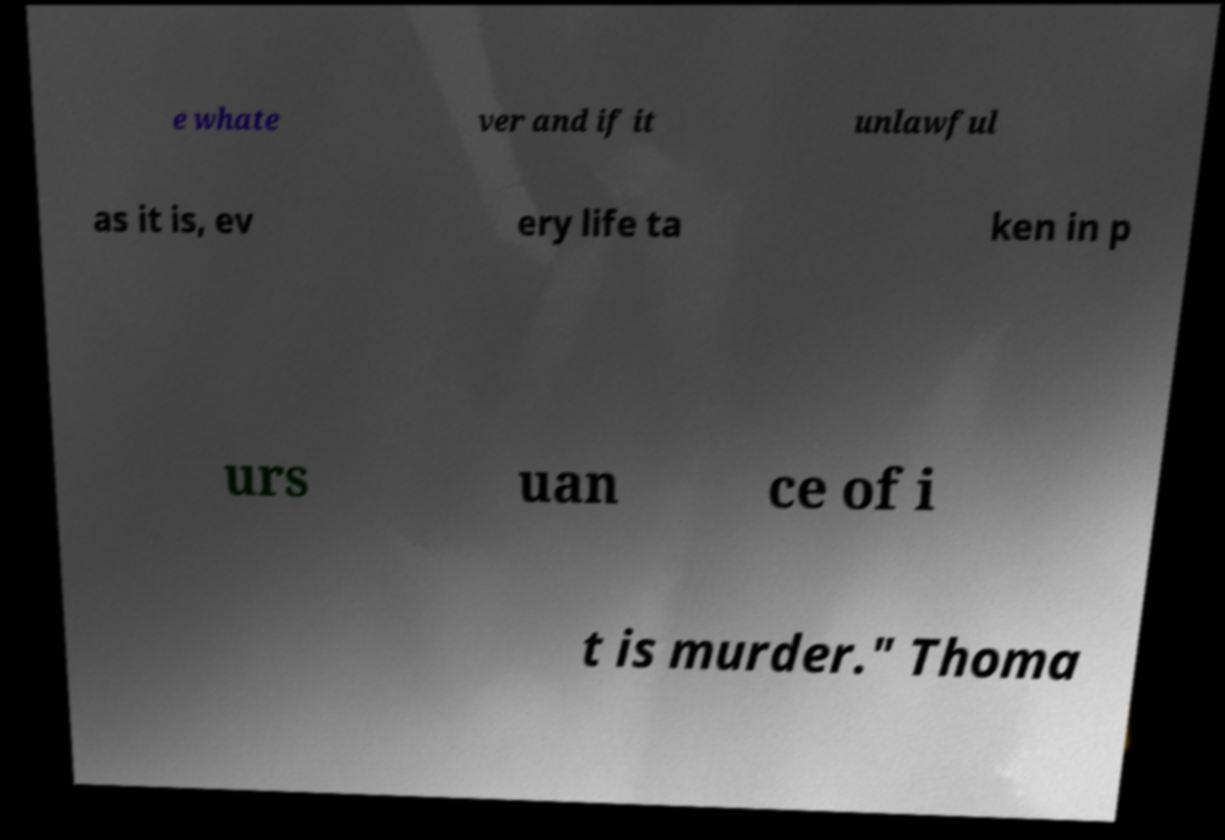Could you extract and type out the text from this image? e whate ver and if it unlawful as it is, ev ery life ta ken in p urs uan ce of i t is murder." Thoma 